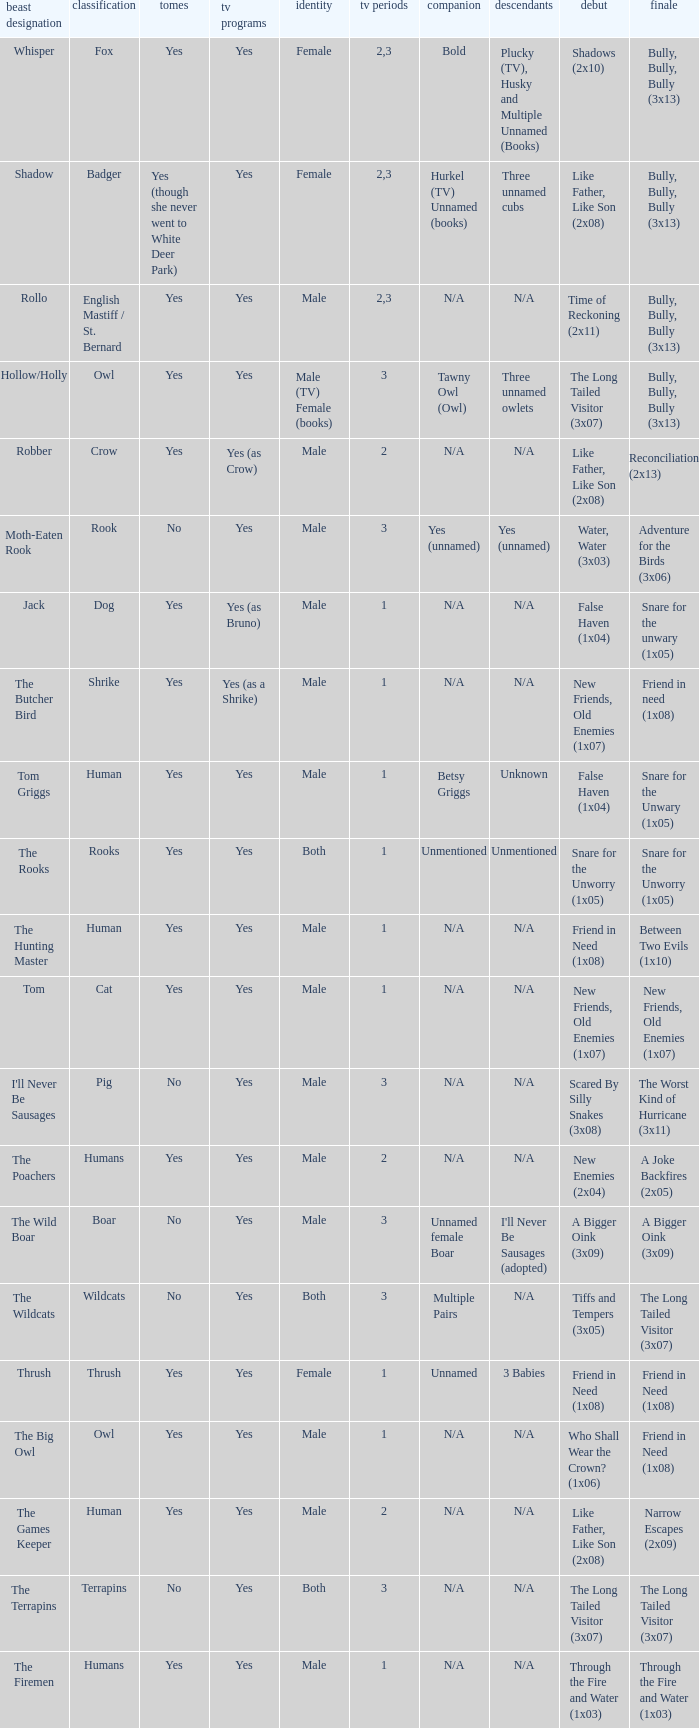What is the smallest season for a tv series with a yes and human was the species? 1.0. 